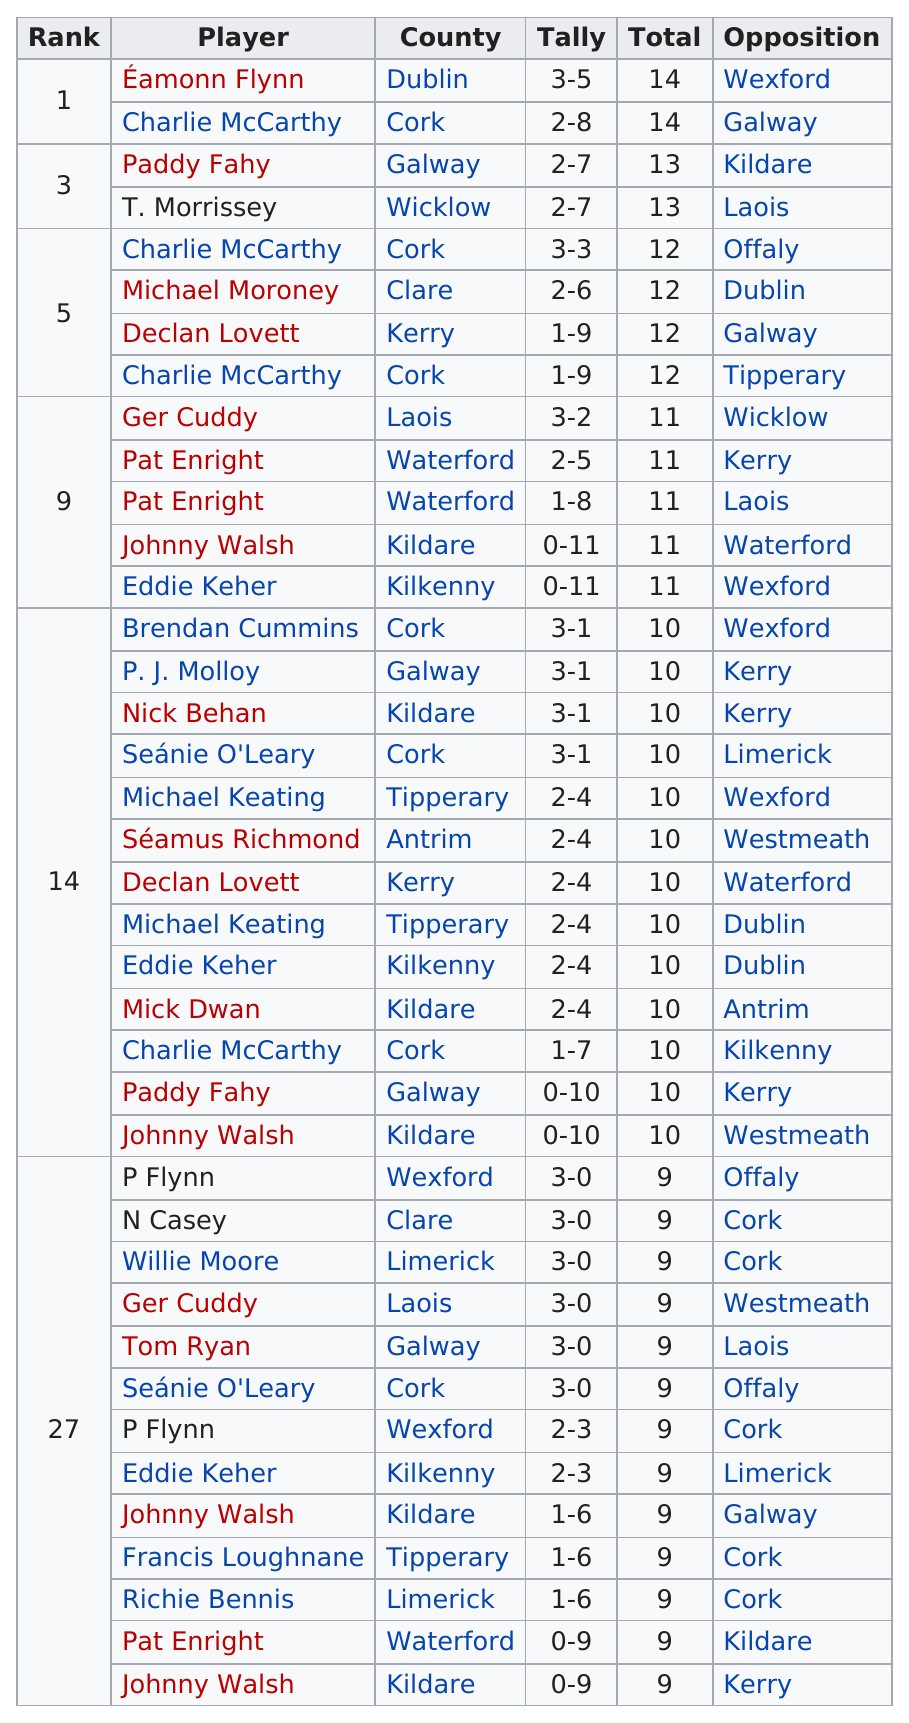Identify some key points in this picture. I am not sure what you are asking for. Can you please provide more context or clarify your question? The individual in the second position of opposition, rank 27, is Offaly. After Declan Lovett, who was ranked next in the 197172 national hurling league, was Charlie McCarthy. It is unclear whether Pat Enright was in rank 5 or rank 9. Seven players are from the city of Cork. 